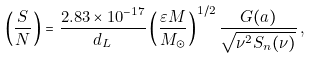Convert formula to latex. <formula><loc_0><loc_0><loc_500><loc_500>\left ( \frac { S } { N } \right ) = \frac { 2 . 8 3 \times 1 0 ^ { - 1 7 } } { d _ { L } } \left ( \frac { \varepsilon M } { M _ { \odot } } \right ) ^ { 1 / 2 } \frac { G ( a ) } { \sqrt { \nu ^ { 2 } S _ { n } ( \nu ) } } \, ,</formula> 